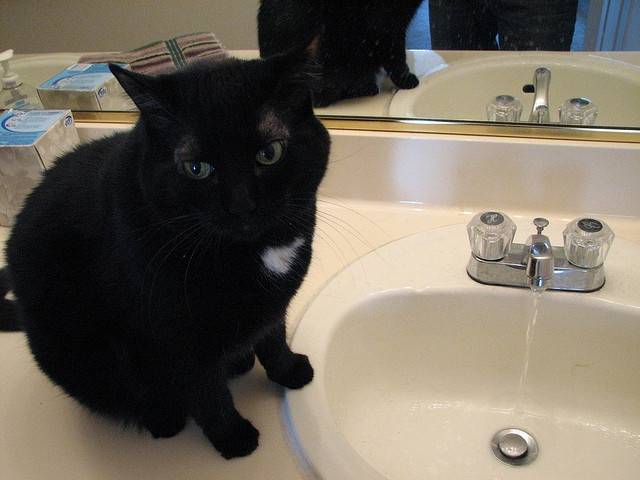Describe the objects in this image and their specific colors. I can see cat in maroon, black, gray, darkgray, and tan tones, sink in maroon, tan, and beige tones, and cat in maroon, black, darkgray, gray, and blue tones in this image. 